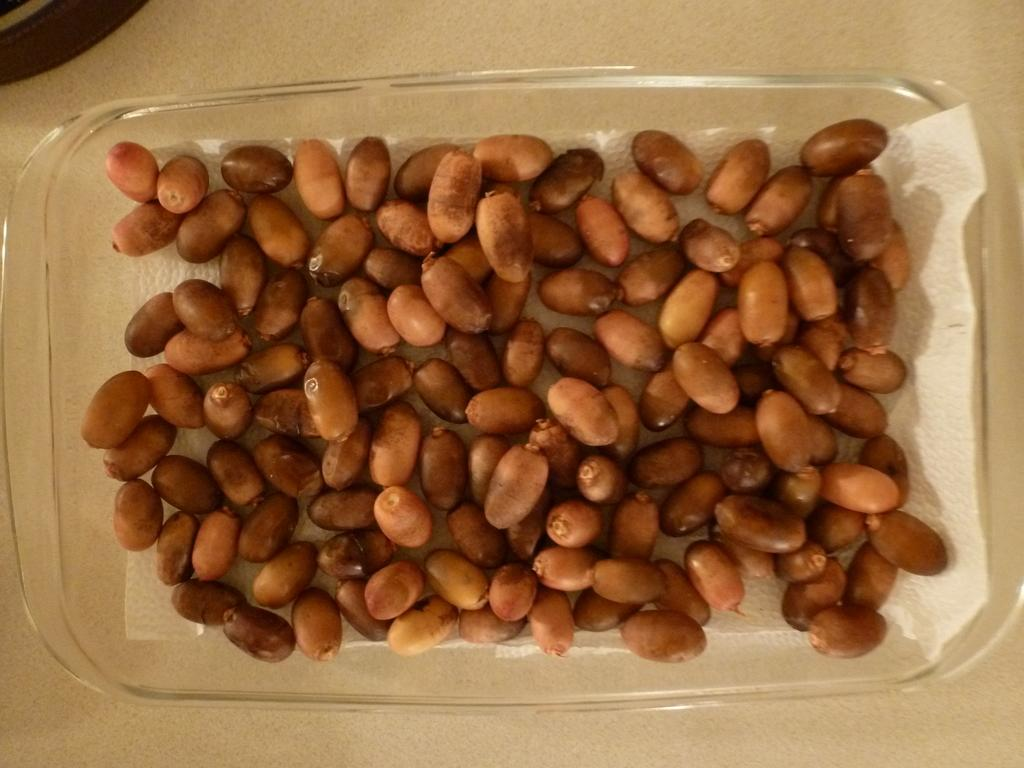What type of plate is visible in the image? There is a transparent plate in the image. What is on the plate? The plate contains red dates. How does the hose help the red dates in the image? There is no hose present in the image, so it cannot help the red dates. 